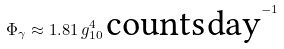Convert formula to latex. <formula><loc_0><loc_0><loc_500><loc_500>\Phi _ { \gamma } \approx 1 . 8 1 \, g _ { 1 0 } ^ { 4 } \, \text {counts} \, \text {day} ^ { - 1 }</formula> 